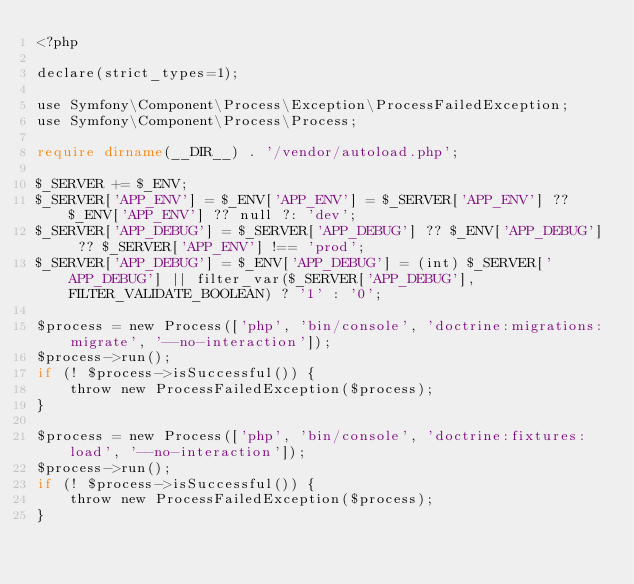<code> <loc_0><loc_0><loc_500><loc_500><_PHP_><?php

declare(strict_types=1);

use Symfony\Component\Process\Exception\ProcessFailedException;
use Symfony\Component\Process\Process;

require dirname(__DIR__) . '/vendor/autoload.php';

$_SERVER += $_ENV;
$_SERVER['APP_ENV'] = $_ENV['APP_ENV'] = $_SERVER['APP_ENV'] ?? $_ENV['APP_ENV'] ?? null ?: 'dev';
$_SERVER['APP_DEBUG'] = $_SERVER['APP_DEBUG'] ?? $_ENV['APP_DEBUG'] ?? $_SERVER['APP_ENV'] !== 'prod';
$_SERVER['APP_DEBUG'] = $_ENV['APP_DEBUG'] = (int) $_SERVER['APP_DEBUG'] || filter_var($_SERVER['APP_DEBUG'], FILTER_VALIDATE_BOOLEAN) ? '1' : '0';

$process = new Process(['php', 'bin/console', 'doctrine:migrations:migrate', '--no-interaction']);
$process->run();
if (! $process->isSuccessful()) {
    throw new ProcessFailedException($process);
}

$process = new Process(['php', 'bin/console', 'doctrine:fixtures:load', '--no-interaction']);
$process->run();
if (! $process->isSuccessful()) {
    throw new ProcessFailedException($process);
}
</code> 